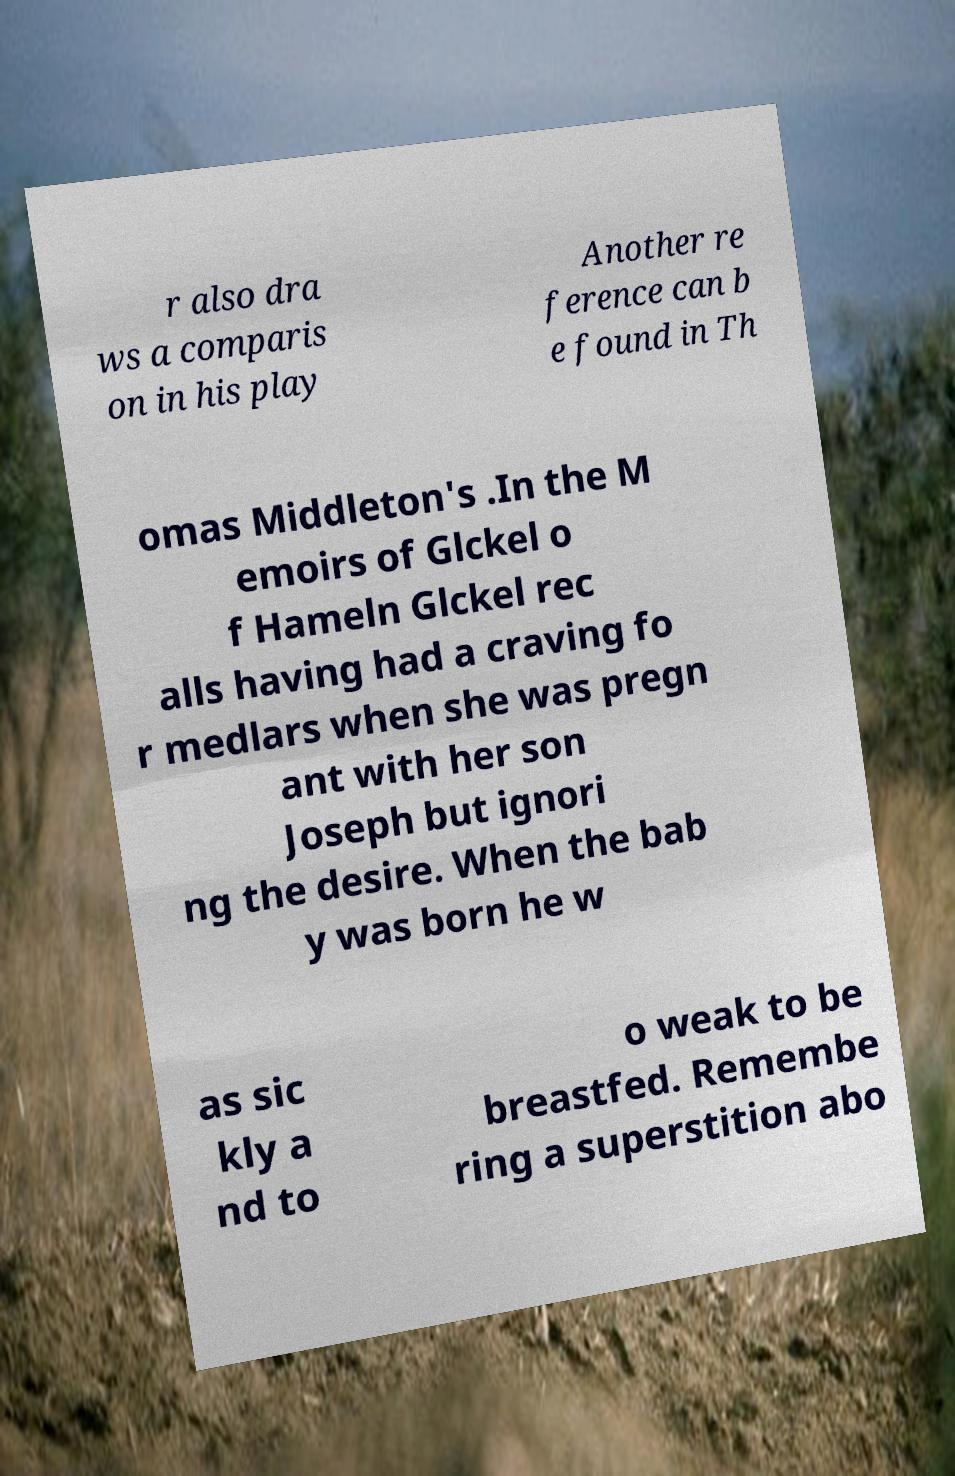There's text embedded in this image that I need extracted. Can you transcribe it verbatim? r also dra ws a comparis on in his play Another re ference can b e found in Th omas Middleton's .In the M emoirs of Glckel o f Hameln Glckel rec alls having had a craving fo r medlars when she was pregn ant with her son Joseph but ignori ng the desire. When the bab y was born he w as sic kly a nd to o weak to be breastfed. Remembe ring a superstition abo 